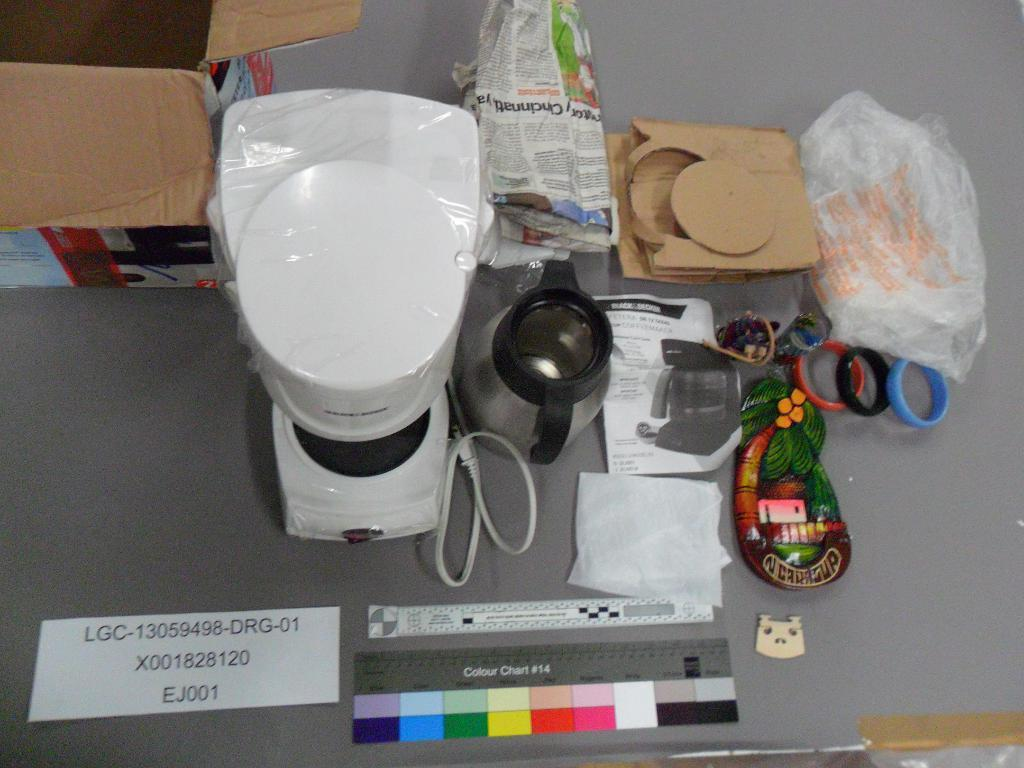<image>
Describe the image concisely. An unboxed coffee maker and other things including a colour chart #14. 